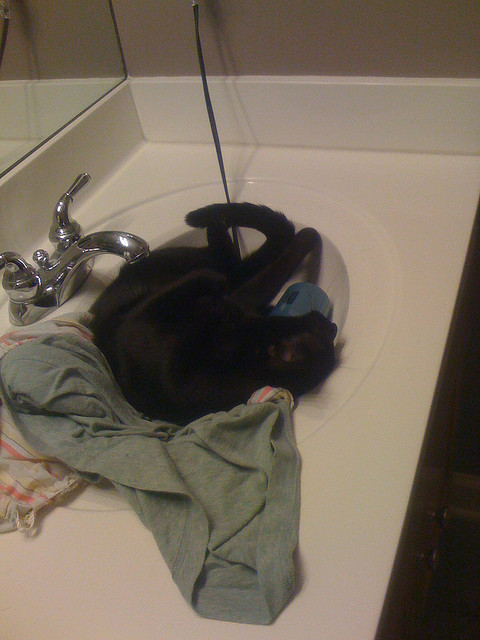What can you infer about the cat's behavior from this image? From this image, we can infer that the cat enjoys finding comfortable spots in unconventional places to rest or play. In this case, it has chosen to lay on clothes and towels in the bathroom sink. The cat appears relaxed, safe, and content in its chosen location. 

Cats are often known for their quirky and curious behavior, and they have an extraordinary ability to adapt to various environments. They tend to seek out cozy or warm places to curl up and rest. This image of the black cat rolling in the sink full of clothes and towels is a perfect example of their unique behavioral traits, showcasing their resourcefulness and charming personalities. Resting in elevated locations such as a sink could also provide them with a sense of security and a vantage point to observe their surroundings, which aligns with their instincts as both predators and prey in the wild. 